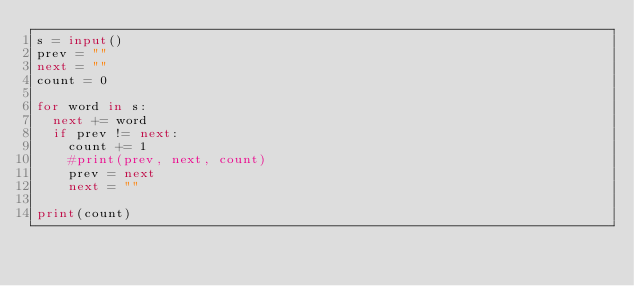<code> <loc_0><loc_0><loc_500><loc_500><_Python_>s = input()
prev = ""
next = ""
count = 0

for word in s:
  next += word
  if prev != next:
    count += 1
    #print(prev, next, count)
    prev = next
    next = ""
    
print(count)</code> 